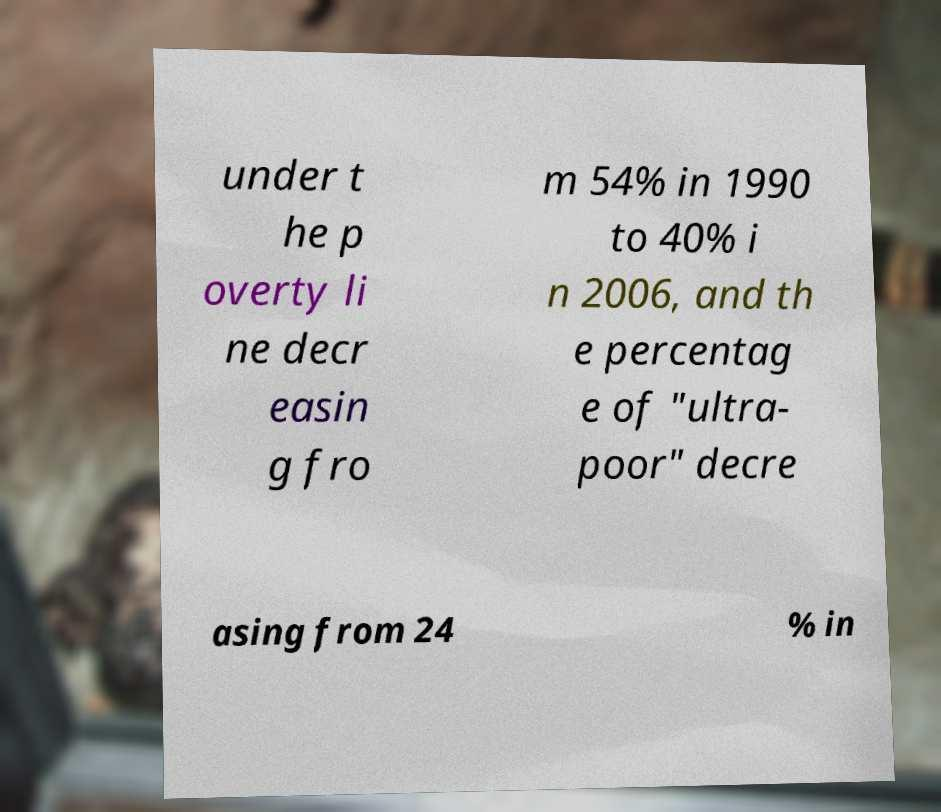Could you extract and type out the text from this image? under t he p overty li ne decr easin g fro m 54% in 1990 to 40% i n 2006, and th e percentag e of "ultra- poor" decre asing from 24 % in 